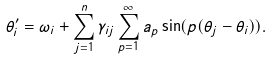Convert formula to latex. <formula><loc_0><loc_0><loc_500><loc_500>\theta _ { i } ^ { \prime } = \omega _ { i } + \sum _ { j = 1 } ^ { n } \gamma _ { i j } \sum _ { p = 1 } ^ { \infty } a _ { p } \sin ( p ( \theta _ { j } - \theta _ { i } ) ) .</formula> 